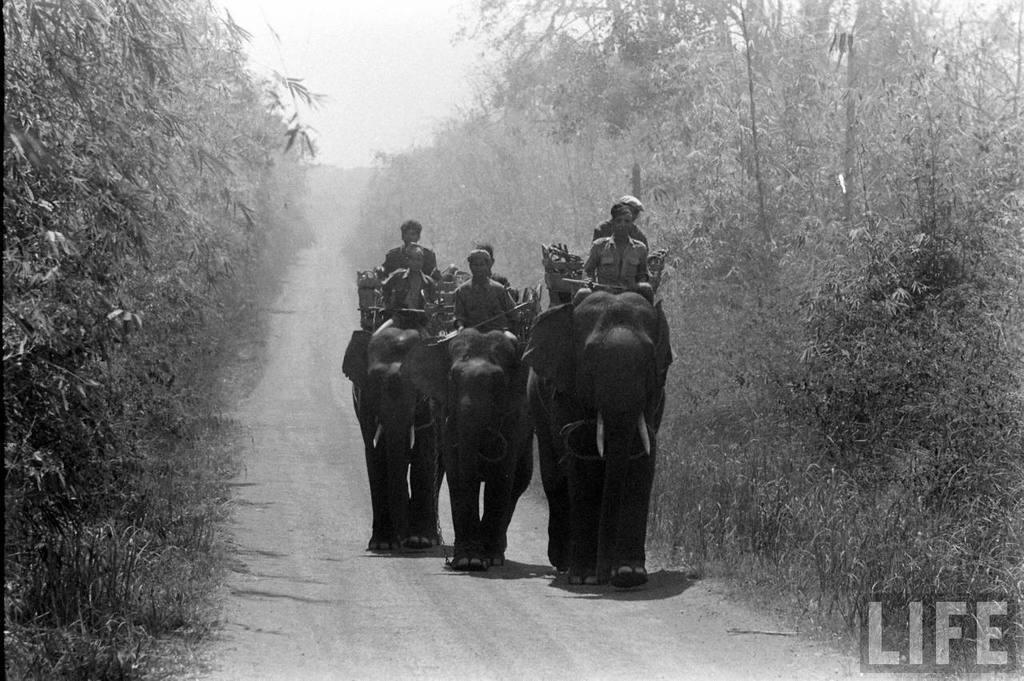What are the persons in the image doing? The persons in the image are sitting on an elephant. What can be seen in the background of the image? There is a sky, trees, and a road visible in the background of the image. What type of silk is being used by the babies to run in the image? There are no babies or silk present in the image. 